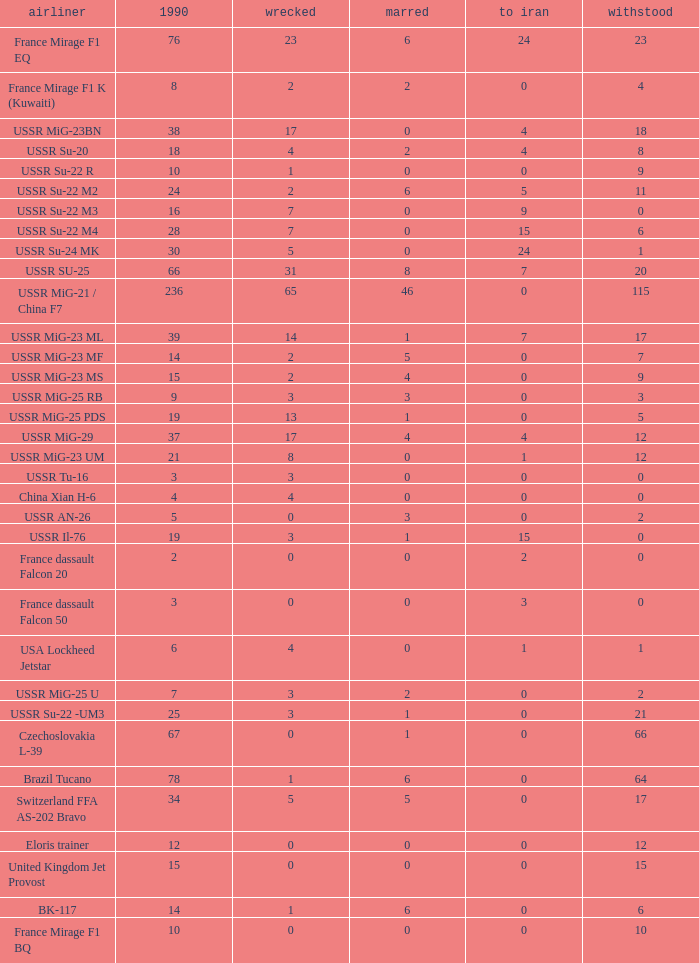If the aircraft was  ussr mig-25 rb how many were destroyed? 3.0. 